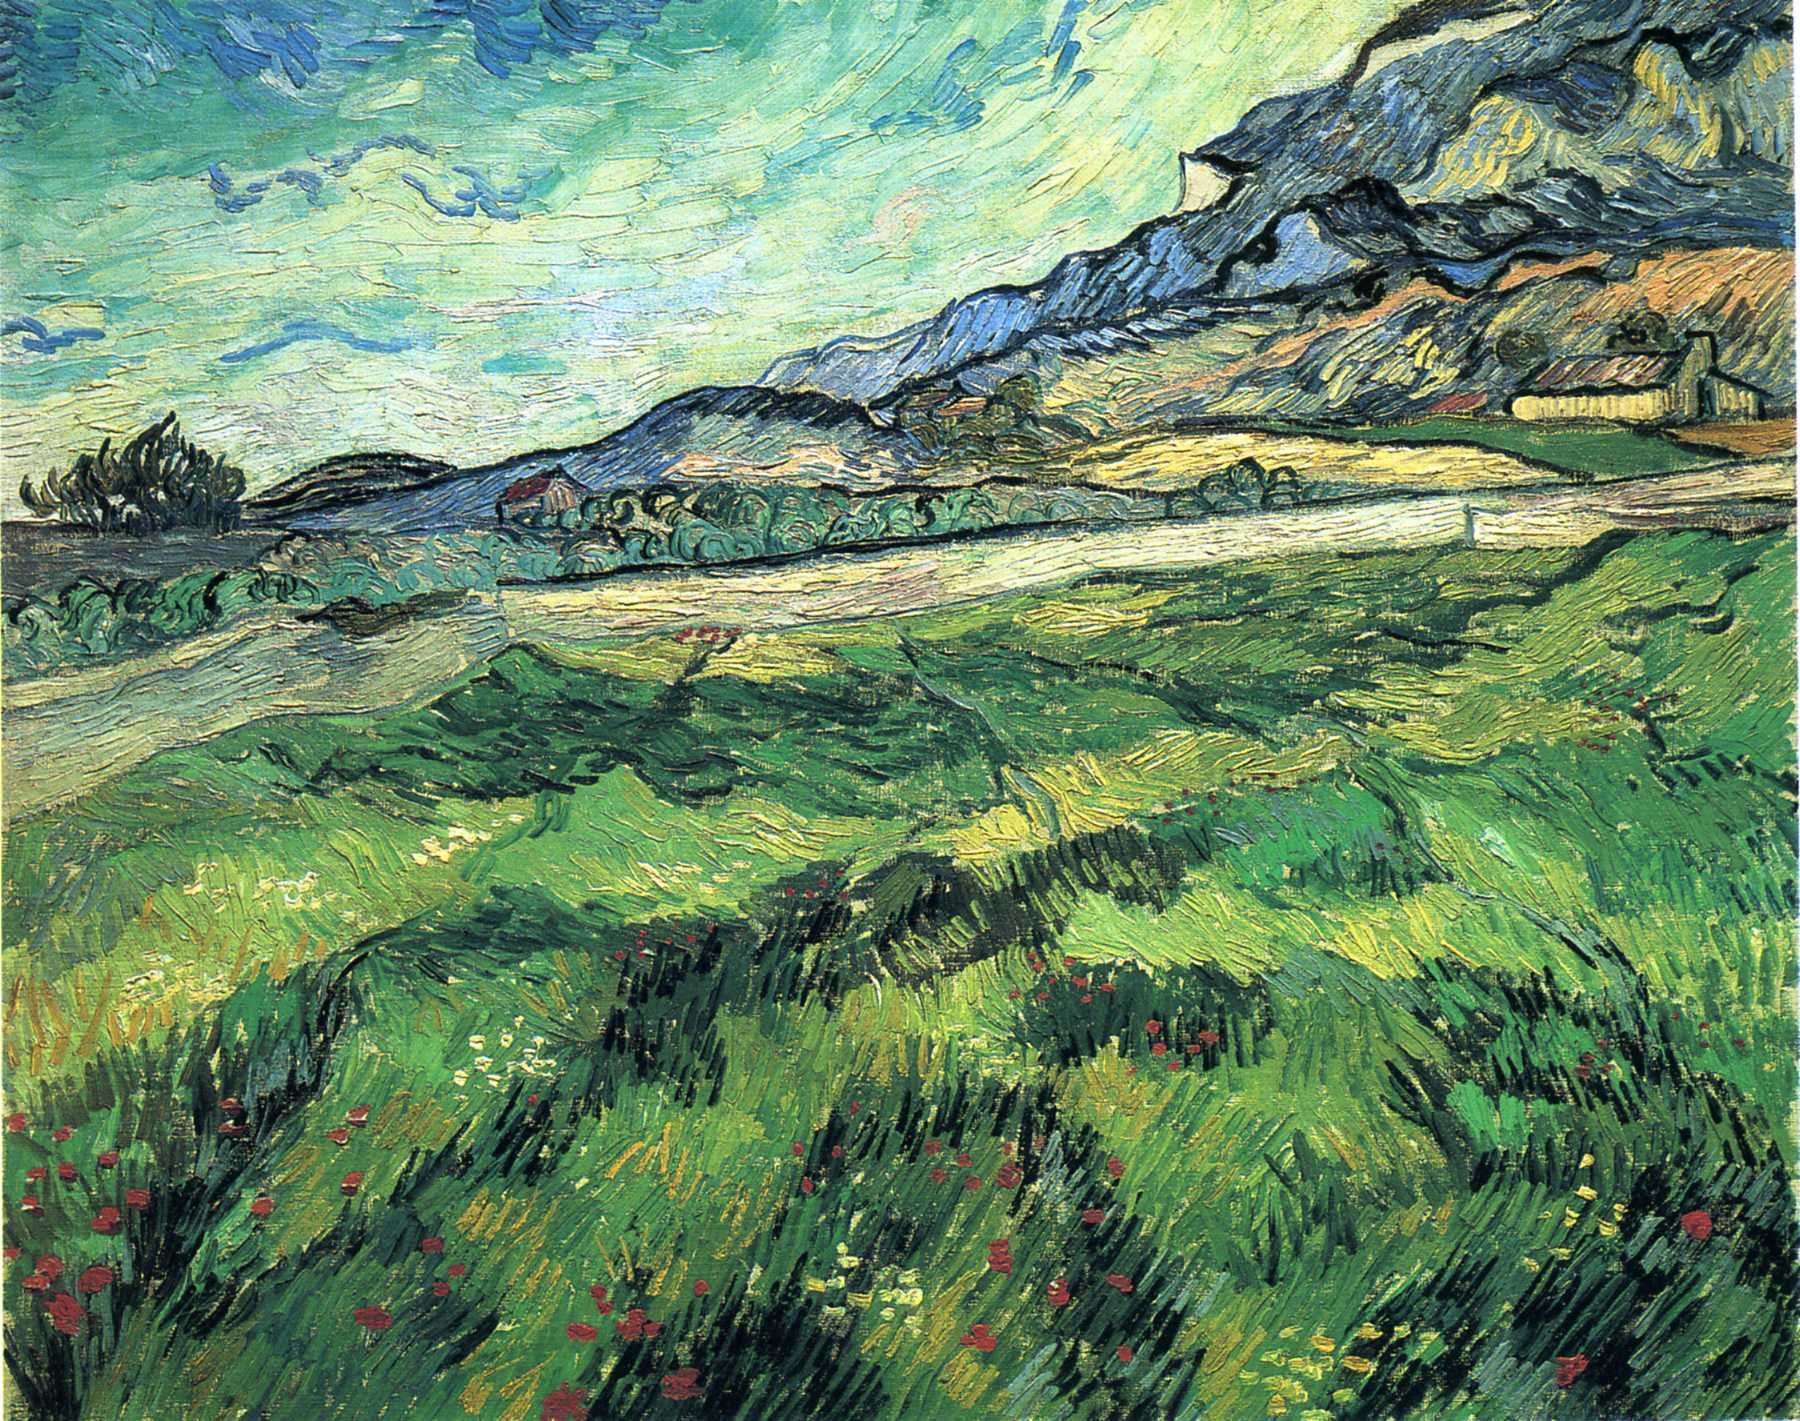Can you elaborate on the elements of the picture provided? The image is a mesmerizing depiction of Vincent Van Gogh's post-impressionist landscape painting. It masterfully illustrates a lush, verdant field alive with the vibrancy of blooming wildflowers. In the distance, a rugged mountain stands tall, its peaks brushing against a sky painted with Van Gogh's signature swirling blue patterns that suggest a dynamic, almost ethereal movement. The dense and expressive brushstrokes in bold greens and yellows bring the field to life, capturing the essence of nature's raw beauty. The painting's striking colors and emotive strokes reflect Van Gogh's unparalleled ability to infuse his works with profound emotional depth, making this landscape a quintessential example of post-impressionism, where the inner feelings of the artist take precedence over realistic portrayal. 